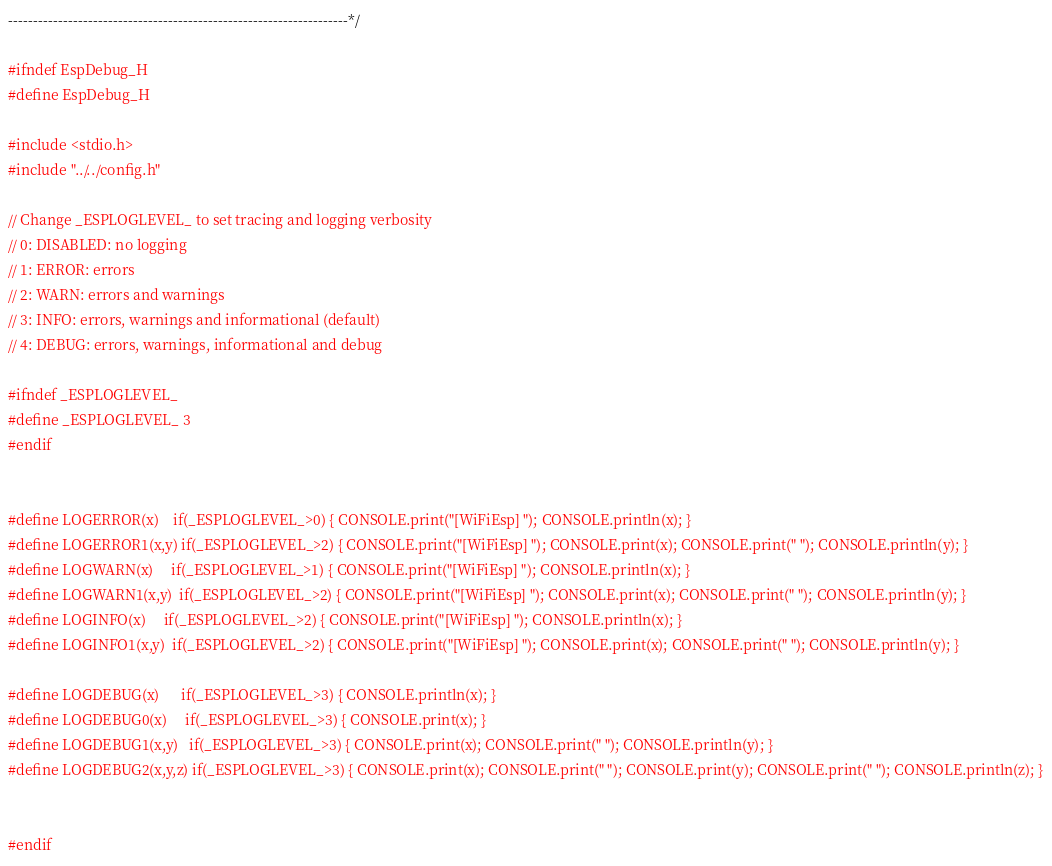<code> <loc_0><loc_0><loc_500><loc_500><_C_>--------------------------------------------------------------------*/

#ifndef EspDebug_H
#define EspDebug_H

#include <stdio.h>
#include "../../config.h"

// Change _ESPLOGLEVEL_ to set tracing and logging verbosity
// 0: DISABLED: no logging
// 1: ERROR: errors
// 2: WARN: errors and warnings
// 3: INFO: errors, warnings and informational (default)
// 4: DEBUG: errors, warnings, informational and debug

#ifndef _ESPLOGLEVEL_
#define _ESPLOGLEVEL_ 3
#endif


#define LOGERROR(x)    if(_ESPLOGLEVEL_>0) { CONSOLE.print("[WiFiEsp] "); CONSOLE.println(x); }
#define LOGERROR1(x,y) if(_ESPLOGLEVEL_>2) { CONSOLE.print("[WiFiEsp] "); CONSOLE.print(x); CONSOLE.print(" "); CONSOLE.println(y); }
#define LOGWARN(x)     if(_ESPLOGLEVEL_>1) { CONSOLE.print("[WiFiEsp] "); CONSOLE.println(x); }
#define LOGWARN1(x,y)  if(_ESPLOGLEVEL_>2) { CONSOLE.print("[WiFiEsp] "); CONSOLE.print(x); CONSOLE.print(" "); CONSOLE.println(y); }
#define LOGINFO(x)     if(_ESPLOGLEVEL_>2) { CONSOLE.print("[WiFiEsp] "); CONSOLE.println(x); }
#define LOGINFO1(x,y)  if(_ESPLOGLEVEL_>2) { CONSOLE.print("[WiFiEsp] "); CONSOLE.print(x); CONSOLE.print(" "); CONSOLE.println(y); }

#define LOGDEBUG(x)      if(_ESPLOGLEVEL_>3) { CONSOLE.println(x); }
#define LOGDEBUG0(x)     if(_ESPLOGLEVEL_>3) { CONSOLE.print(x); }
#define LOGDEBUG1(x,y)   if(_ESPLOGLEVEL_>3) { CONSOLE.print(x); CONSOLE.print(" "); CONSOLE.println(y); }
#define LOGDEBUG2(x,y,z) if(_ESPLOGLEVEL_>3) { CONSOLE.print(x); CONSOLE.print(" "); CONSOLE.print(y); CONSOLE.print(" "); CONSOLE.println(z); }


#endif
</code> 